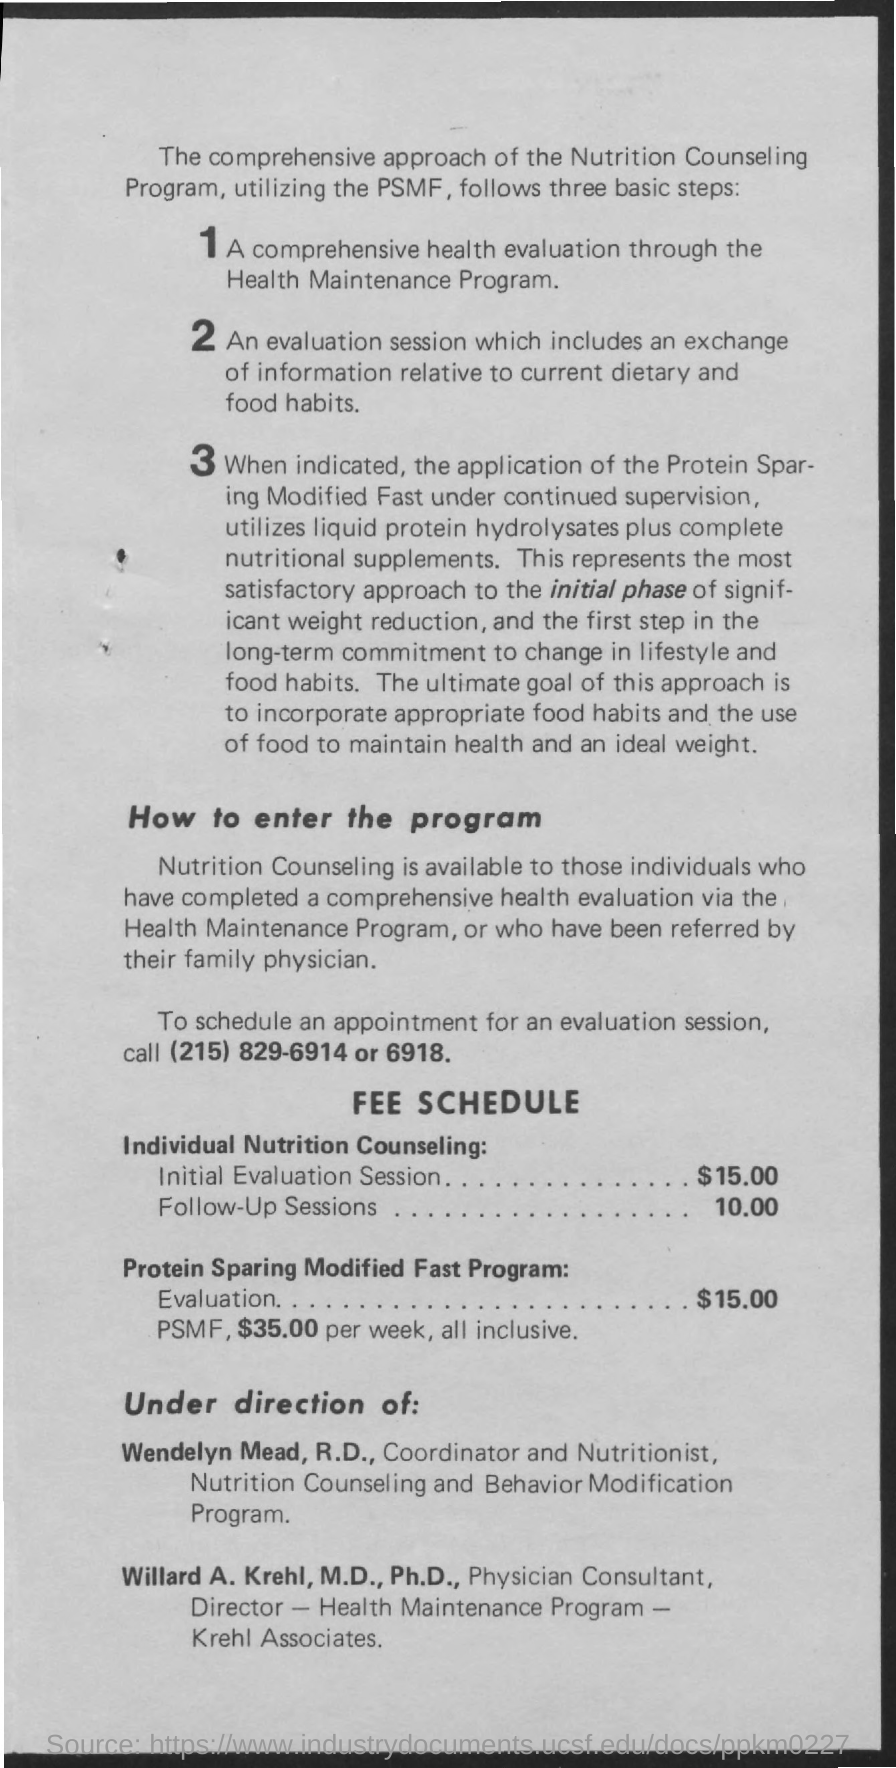What is the number given to schedule an appointment for an evaluation session?
Provide a succinct answer. (215) 829-6914 or 6918. What is the fee for initial evaluation session in the individual nutrition counseling ?
Provide a short and direct response. $ 15.00. What is the fee for the follow-up sessions in the individual nutrition counseling ?
Offer a very short reply. 10.00. What is the fee for evaluation of protein sparing modified fast program ?
Offer a terse response. $15.00. Who is the coordinator and nutritionist ,nutrition counseling and behavior modification program ?
Offer a very short reply. Wendelyn mead. 